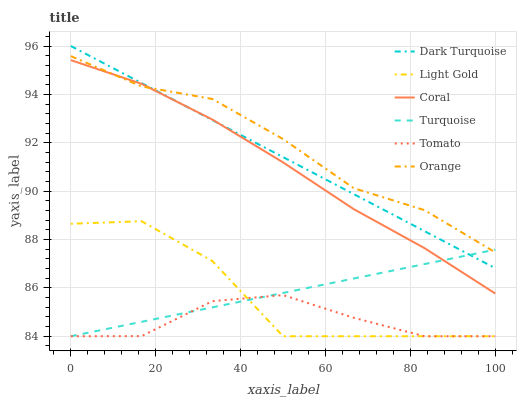Does Tomato have the minimum area under the curve?
Answer yes or no. Yes. Does Orange have the maximum area under the curve?
Answer yes or no. Yes. Does Turquoise have the minimum area under the curve?
Answer yes or no. No. Does Turquoise have the maximum area under the curve?
Answer yes or no. No. Is Dark Turquoise the smoothest?
Answer yes or no. Yes. Is Light Gold the roughest?
Answer yes or no. Yes. Is Turquoise the smoothest?
Answer yes or no. No. Is Turquoise the roughest?
Answer yes or no. No. Does Dark Turquoise have the lowest value?
Answer yes or no. No. Does Dark Turquoise have the highest value?
Answer yes or no. Yes. Does Turquoise have the highest value?
Answer yes or no. No. Is Light Gold less than Coral?
Answer yes or no. Yes. Is Coral greater than Tomato?
Answer yes or no. Yes. Does Turquoise intersect Light Gold?
Answer yes or no. Yes. Is Turquoise less than Light Gold?
Answer yes or no. No. Is Turquoise greater than Light Gold?
Answer yes or no. No. Does Light Gold intersect Coral?
Answer yes or no. No. 